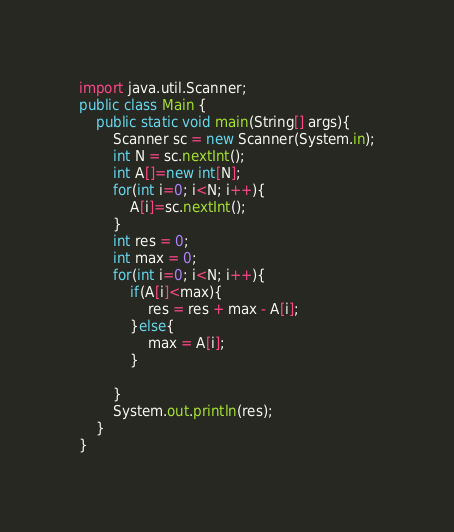Convert code to text. <code><loc_0><loc_0><loc_500><loc_500><_Java_>import java.util.Scanner;
public class Main {
	public static void main(String[] args){
		Scanner sc = new Scanner(System.in);
		int N = sc.nextInt();
        int A[]=new int[N];
        for(int i=0; i<N; i++){
            A[i]=sc.nextInt();
        }
        int res = 0;
        int max = 0;
        for(int i=0; i<N; i++){
            if(A[i]<max){
                res = res + max - A[i];
            }else{
                max = A[i];
            }
            
        }
		System.out.println(res);
	}
}</code> 